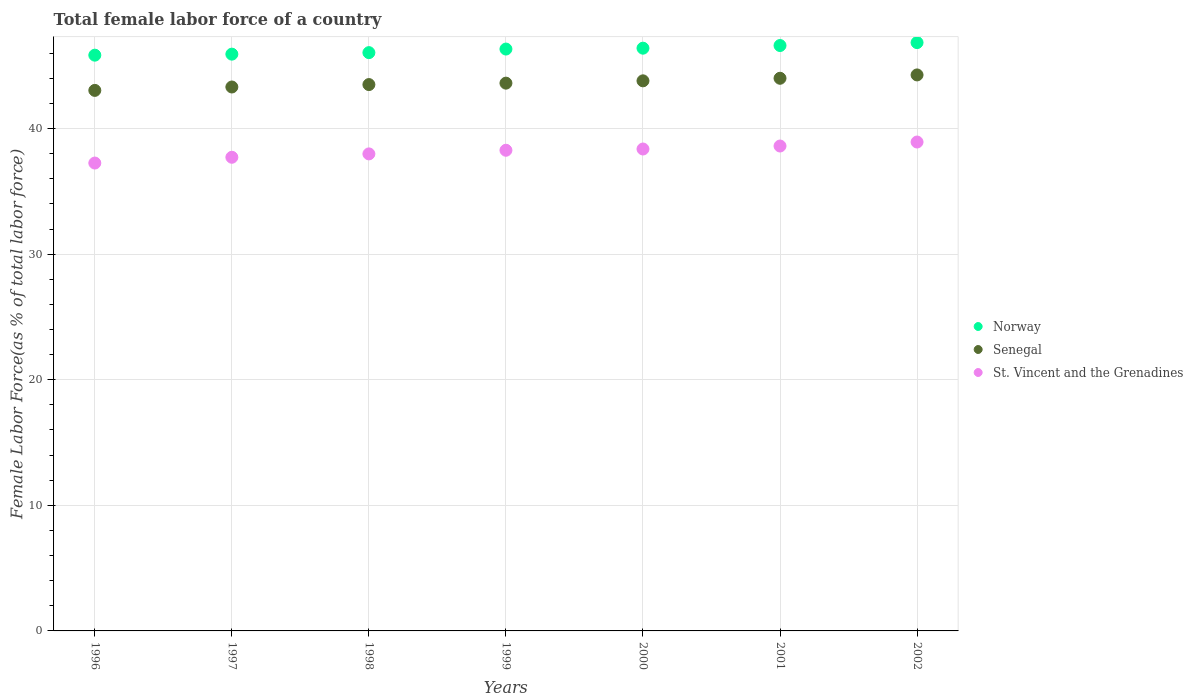Is the number of dotlines equal to the number of legend labels?
Offer a terse response. Yes. What is the percentage of female labor force in Norway in 2002?
Keep it short and to the point. 46.85. Across all years, what is the maximum percentage of female labor force in St. Vincent and the Grenadines?
Provide a short and direct response. 38.93. Across all years, what is the minimum percentage of female labor force in Norway?
Your answer should be compact. 45.85. In which year was the percentage of female labor force in St. Vincent and the Grenadines maximum?
Your response must be concise. 2002. In which year was the percentage of female labor force in St. Vincent and the Grenadines minimum?
Your response must be concise. 1996. What is the total percentage of female labor force in Senegal in the graph?
Your answer should be compact. 305.56. What is the difference between the percentage of female labor force in St. Vincent and the Grenadines in 1998 and that in 2001?
Offer a terse response. -0.63. What is the difference between the percentage of female labor force in Norway in 1998 and the percentage of female labor force in Senegal in 1997?
Provide a short and direct response. 2.74. What is the average percentage of female labor force in Senegal per year?
Keep it short and to the point. 43.65. In the year 1999, what is the difference between the percentage of female labor force in St. Vincent and the Grenadines and percentage of female labor force in Norway?
Keep it short and to the point. -8.06. In how many years, is the percentage of female labor force in Senegal greater than 34 %?
Offer a very short reply. 7. What is the ratio of the percentage of female labor force in Norway in 1997 to that in 1999?
Your answer should be compact. 0.99. Is the percentage of female labor force in Senegal in 1999 less than that in 2000?
Your response must be concise. Yes. What is the difference between the highest and the second highest percentage of female labor force in Senegal?
Provide a succinct answer. 0.27. What is the difference between the highest and the lowest percentage of female labor force in Norway?
Provide a succinct answer. 1. Is the sum of the percentage of female labor force in Senegal in 1999 and 2001 greater than the maximum percentage of female labor force in St. Vincent and the Grenadines across all years?
Keep it short and to the point. Yes. Is it the case that in every year, the sum of the percentage of female labor force in Norway and percentage of female labor force in Senegal  is greater than the percentage of female labor force in St. Vincent and the Grenadines?
Make the answer very short. Yes. Is the percentage of female labor force in Senegal strictly greater than the percentage of female labor force in St. Vincent and the Grenadines over the years?
Make the answer very short. Yes. Is the percentage of female labor force in St. Vincent and the Grenadines strictly less than the percentage of female labor force in Senegal over the years?
Your response must be concise. Yes. How many dotlines are there?
Provide a succinct answer. 3. How many legend labels are there?
Your answer should be compact. 3. What is the title of the graph?
Give a very brief answer. Total female labor force of a country. What is the label or title of the X-axis?
Your response must be concise. Years. What is the label or title of the Y-axis?
Your response must be concise. Female Labor Force(as % of total labor force). What is the Female Labor Force(as % of total labor force) in Norway in 1996?
Keep it short and to the point. 45.85. What is the Female Labor Force(as % of total labor force) of Senegal in 1996?
Keep it short and to the point. 43.04. What is the Female Labor Force(as % of total labor force) of St. Vincent and the Grenadines in 1996?
Your response must be concise. 37.26. What is the Female Labor Force(as % of total labor force) in Norway in 1997?
Your response must be concise. 45.93. What is the Female Labor Force(as % of total labor force) in Senegal in 1997?
Keep it short and to the point. 43.31. What is the Female Labor Force(as % of total labor force) of St. Vincent and the Grenadines in 1997?
Offer a very short reply. 37.72. What is the Female Labor Force(as % of total labor force) of Norway in 1998?
Keep it short and to the point. 46.05. What is the Female Labor Force(as % of total labor force) in Senegal in 1998?
Offer a very short reply. 43.51. What is the Female Labor Force(as % of total labor force) of St. Vincent and the Grenadines in 1998?
Offer a very short reply. 37.99. What is the Female Labor Force(as % of total labor force) of Norway in 1999?
Provide a succinct answer. 46.33. What is the Female Labor Force(as % of total labor force) of Senegal in 1999?
Offer a terse response. 43.62. What is the Female Labor Force(as % of total labor force) in St. Vincent and the Grenadines in 1999?
Provide a succinct answer. 38.27. What is the Female Labor Force(as % of total labor force) of Norway in 2000?
Provide a short and direct response. 46.4. What is the Female Labor Force(as % of total labor force) of Senegal in 2000?
Your answer should be compact. 43.8. What is the Female Labor Force(as % of total labor force) in St. Vincent and the Grenadines in 2000?
Your answer should be very brief. 38.37. What is the Female Labor Force(as % of total labor force) in Norway in 2001?
Provide a short and direct response. 46.61. What is the Female Labor Force(as % of total labor force) in Senegal in 2001?
Provide a short and direct response. 44.01. What is the Female Labor Force(as % of total labor force) of St. Vincent and the Grenadines in 2001?
Keep it short and to the point. 38.61. What is the Female Labor Force(as % of total labor force) in Norway in 2002?
Ensure brevity in your answer.  46.85. What is the Female Labor Force(as % of total labor force) in Senegal in 2002?
Provide a short and direct response. 44.27. What is the Female Labor Force(as % of total labor force) of St. Vincent and the Grenadines in 2002?
Give a very brief answer. 38.93. Across all years, what is the maximum Female Labor Force(as % of total labor force) in Norway?
Keep it short and to the point. 46.85. Across all years, what is the maximum Female Labor Force(as % of total labor force) in Senegal?
Make the answer very short. 44.27. Across all years, what is the maximum Female Labor Force(as % of total labor force) in St. Vincent and the Grenadines?
Your answer should be very brief. 38.93. Across all years, what is the minimum Female Labor Force(as % of total labor force) of Norway?
Provide a succinct answer. 45.85. Across all years, what is the minimum Female Labor Force(as % of total labor force) of Senegal?
Offer a very short reply. 43.04. Across all years, what is the minimum Female Labor Force(as % of total labor force) of St. Vincent and the Grenadines?
Your response must be concise. 37.26. What is the total Female Labor Force(as % of total labor force) in Norway in the graph?
Your response must be concise. 324.02. What is the total Female Labor Force(as % of total labor force) of Senegal in the graph?
Provide a succinct answer. 305.56. What is the total Female Labor Force(as % of total labor force) in St. Vincent and the Grenadines in the graph?
Your response must be concise. 267.15. What is the difference between the Female Labor Force(as % of total labor force) of Norway in 1996 and that in 1997?
Offer a very short reply. -0.08. What is the difference between the Female Labor Force(as % of total labor force) in Senegal in 1996 and that in 1997?
Ensure brevity in your answer.  -0.27. What is the difference between the Female Labor Force(as % of total labor force) in St. Vincent and the Grenadines in 1996 and that in 1997?
Offer a very short reply. -0.46. What is the difference between the Female Labor Force(as % of total labor force) in Norway in 1996 and that in 1998?
Ensure brevity in your answer.  -0.2. What is the difference between the Female Labor Force(as % of total labor force) of Senegal in 1996 and that in 1998?
Provide a short and direct response. -0.46. What is the difference between the Female Labor Force(as % of total labor force) of St. Vincent and the Grenadines in 1996 and that in 1998?
Your answer should be very brief. -0.73. What is the difference between the Female Labor Force(as % of total labor force) of Norway in 1996 and that in 1999?
Ensure brevity in your answer.  -0.49. What is the difference between the Female Labor Force(as % of total labor force) in Senegal in 1996 and that in 1999?
Your answer should be compact. -0.58. What is the difference between the Female Labor Force(as % of total labor force) of St. Vincent and the Grenadines in 1996 and that in 1999?
Provide a succinct answer. -1.02. What is the difference between the Female Labor Force(as % of total labor force) of Norway in 1996 and that in 2000?
Keep it short and to the point. -0.56. What is the difference between the Female Labor Force(as % of total labor force) of Senegal in 1996 and that in 2000?
Make the answer very short. -0.76. What is the difference between the Female Labor Force(as % of total labor force) of St. Vincent and the Grenadines in 1996 and that in 2000?
Offer a very short reply. -1.12. What is the difference between the Female Labor Force(as % of total labor force) in Norway in 1996 and that in 2001?
Your answer should be compact. -0.77. What is the difference between the Female Labor Force(as % of total labor force) in Senegal in 1996 and that in 2001?
Offer a very short reply. -0.97. What is the difference between the Female Labor Force(as % of total labor force) in St. Vincent and the Grenadines in 1996 and that in 2001?
Offer a terse response. -1.36. What is the difference between the Female Labor Force(as % of total labor force) in Norway in 1996 and that in 2002?
Offer a terse response. -1. What is the difference between the Female Labor Force(as % of total labor force) in Senegal in 1996 and that in 2002?
Provide a short and direct response. -1.23. What is the difference between the Female Labor Force(as % of total labor force) in St. Vincent and the Grenadines in 1996 and that in 2002?
Offer a very short reply. -1.67. What is the difference between the Female Labor Force(as % of total labor force) of Norway in 1997 and that in 1998?
Give a very brief answer. -0.12. What is the difference between the Female Labor Force(as % of total labor force) in Senegal in 1997 and that in 1998?
Provide a short and direct response. -0.19. What is the difference between the Female Labor Force(as % of total labor force) in St. Vincent and the Grenadines in 1997 and that in 1998?
Your response must be concise. -0.27. What is the difference between the Female Labor Force(as % of total labor force) of Norway in 1997 and that in 1999?
Give a very brief answer. -0.41. What is the difference between the Female Labor Force(as % of total labor force) of Senegal in 1997 and that in 1999?
Offer a very short reply. -0.31. What is the difference between the Female Labor Force(as % of total labor force) of St. Vincent and the Grenadines in 1997 and that in 1999?
Make the answer very short. -0.56. What is the difference between the Female Labor Force(as % of total labor force) in Norway in 1997 and that in 2000?
Your answer should be very brief. -0.48. What is the difference between the Female Labor Force(as % of total labor force) in Senegal in 1997 and that in 2000?
Ensure brevity in your answer.  -0.49. What is the difference between the Female Labor Force(as % of total labor force) in St. Vincent and the Grenadines in 1997 and that in 2000?
Provide a succinct answer. -0.66. What is the difference between the Female Labor Force(as % of total labor force) of Norway in 1997 and that in 2001?
Ensure brevity in your answer.  -0.69. What is the difference between the Female Labor Force(as % of total labor force) in Senegal in 1997 and that in 2001?
Make the answer very short. -0.69. What is the difference between the Female Labor Force(as % of total labor force) of St. Vincent and the Grenadines in 1997 and that in 2001?
Give a very brief answer. -0.9. What is the difference between the Female Labor Force(as % of total labor force) of Norway in 1997 and that in 2002?
Make the answer very short. -0.92. What is the difference between the Female Labor Force(as % of total labor force) in Senegal in 1997 and that in 2002?
Provide a succinct answer. -0.96. What is the difference between the Female Labor Force(as % of total labor force) of St. Vincent and the Grenadines in 1997 and that in 2002?
Provide a short and direct response. -1.21. What is the difference between the Female Labor Force(as % of total labor force) in Norway in 1998 and that in 1999?
Keep it short and to the point. -0.28. What is the difference between the Female Labor Force(as % of total labor force) in Senegal in 1998 and that in 1999?
Your answer should be very brief. -0.11. What is the difference between the Female Labor Force(as % of total labor force) in St. Vincent and the Grenadines in 1998 and that in 1999?
Provide a short and direct response. -0.29. What is the difference between the Female Labor Force(as % of total labor force) of Norway in 1998 and that in 2000?
Provide a succinct answer. -0.35. What is the difference between the Female Labor Force(as % of total labor force) in Senegal in 1998 and that in 2000?
Offer a terse response. -0.3. What is the difference between the Female Labor Force(as % of total labor force) in St. Vincent and the Grenadines in 1998 and that in 2000?
Offer a terse response. -0.39. What is the difference between the Female Labor Force(as % of total labor force) of Norway in 1998 and that in 2001?
Your response must be concise. -0.57. What is the difference between the Female Labor Force(as % of total labor force) in Senegal in 1998 and that in 2001?
Make the answer very short. -0.5. What is the difference between the Female Labor Force(as % of total labor force) of St. Vincent and the Grenadines in 1998 and that in 2001?
Keep it short and to the point. -0.63. What is the difference between the Female Labor Force(as % of total labor force) of Norway in 1998 and that in 2002?
Keep it short and to the point. -0.8. What is the difference between the Female Labor Force(as % of total labor force) in Senegal in 1998 and that in 2002?
Ensure brevity in your answer.  -0.77. What is the difference between the Female Labor Force(as % of total labor force) of St. Vincent and the Grenadines in 1998 and that in 2002?
Give a very brief answer. -0.95. What is the difference between the Female Labor Force(as % of total labor force) of Norway in 1999 and that in 2000?
Ensure brevity in your answer.  -0.07. What is the difference between the Female Labor Force(as % of total labor force) of Senegal in 1999 and that in 2000?
Your answer should be compact. -0.18. What is the difference between the Female Labor Force(as % of total labor force) in St. Vincent and the Grenadines in 1999 and that in 2000?
Your response must be concise. -0.1. What is the difference between the Female Labor Force(as % of total labor force) of Norway in 1999 and that in 2001?
Ensure brevity in your answer.  -0.28. What is the difference between the Female Labor Force(as % of total labor force) in Senegal in 1999 and that in 2001?
Your answer should be compact. -0.39. What is the difference between the Female Labor Force(as % of total labor force) in St. Vincent and the Grenadines in 1999 and that in 2001?
Keep it short and to the point. -0.34. What is the difference between the Female Labor Force(as % of total labor force) in Norway in 1999 and that in 2002?
Give a very brief answer. -0.51. What is the difference between the Female Labor Force(as % of total labor force) in Senegal in 1999 and that in 2002?
Offer a very short reply. -0.65. What is the difference between the Female Labor Force(as % of total labor force) of St. Vincent and the Grenadines in 1999 and that in 2002?
Provide a short and direct response. -0.66. What is the difference between the Female Labor Force(as % of total labor force) of Norway in 2000 and that in 2001?
Provide a short and direct response. -0.21. What is the difference between the Female Labor Force(as % of total labor force) of Senegal in 2000 and that in 2001?
Your answer should be compact. -0.2. What is the difference between the Female Labor Force(as % of total labor force) in St. Vincent and the Grenadines in 2000 and that in 2001?
Provide a succinct answer. -0.24. What is the difference between the Female Labor Force(as % of total labor force) of Norway in 2000 and that in 2002?
Offer a terse response. -0.44. What is the difference between the Female Labor Force(as % of total labor force) of Senegal in 2000 and that in 2002?
Give a very brief answer. -0.47. What is the difference between the Female Labor Force(as % of total labor force) in St. Vincent and the Grenadines in 2000 and that in 2002?
Provide a succinct answer. -0.56. What is the difference between the Female Labor Force(as % of total labor force) in Norway in 2001 and that in 2002?
Your response must be concise. -0.23. What is the difference between the Female Labor Force(as % of total labor force) of Senegal in 2001 and that in 2002?
Offer a terse response. -0.27. What is the difference between the Female Labor Force(as % of total labor force) in St. Vincent and the Grenadines in 2001 and that in 2002?
Provide a short and direct response. -0.32. What is the difference between the Female Labor Force(as % of total labor force) of Norway in 1996 and the Female Labor Force(as % of total labor force) of Senegal in 1997?
Offer a very short reply. 2.53. What is the difference between the Female Labor Force(as % of total labor force) in Norway in 1996 and the Female Labor Force(as % of total labor force) in St. Vincent and the Grenadines in 1997?
Make the answer very short. 8.13. What is the difference between the Female Labor Force(as % of total labor force) of Senegal in 1996 and the Female Labor Force(as % of total labor force) of St. Vincent and the Grenadines in 1997?
Keep it short and to the point. 5.33. What is the difference between the Female Labor Force(as % of total labor force) of Norway in 1996 and the Female Labor Force(as % of total labor force) of Senegal in 1998?
Make the answer very short. 2.34. What is the difference between the Female Labor Force(as % of total labor force) in Norway in 1996 and the Female Labor Force(as % of total labor force) in St. Vincent and the Grenadines in 1998?
Make the answer very short. 7.86. What is the difference between the Female Labor Force(as % of total labor force) of Senegal in 1996 and the Female Labor Force(as % of total labor force) of St. Vincent and the Grenadines in 1998?
Provide a succinct answer. 5.06. What is the difference between the Female Labor Force(as % of total labor force) in Norway in 1996 and the Female Labor Force(as % of total labor force) in Senegal in 1999?
Provide a succinct answer. 2.23. What is the difference between the Female Labor Force(as % of total labor force) in Norway in 1996 and the Female Labor Force(as % of total labor force) in St. Vincent and the Grenadines in 1999?
Your response must be concise. 7.57. What is the difference between the Female Labor Force(as % of total labor force) in Senegal in 1996 and the Female Labor Force(as % of total labor force) in St. Vincent and the Grenadines in 1999?
Give a very brief answer. 4.77. What is the difference between the Female Labor Force(as % of total labor force) of Norway in 1996 and the Female Labor Force(as % of total labor force) of Senegal in 2000?
Give a very brief answer. 2.04. What is the difference between the Female Labor Force(as % of total labor force) of Norway in 1996 and the Female Labor Force(as % of total labor force) of St. Vincent and the Grenadines in 2000?
Keep it short and to the point. 7.47. What is the difference between the Female Labor Force(as % of total labor force) of Senegal in 1996 and the Female Labor Force(as % of total labor force) of St. Vincent and the Grenadines in 2000?
Ensure brevity in your answer.  4.67. What is the difference between the Female Labor Force(as % of total labor force) in Norway in 1996 and the Female Labor Force(as % of total labor force) in Senegal in 2001?
Your response must be concise. 1.84. What is the difference between the Female Labor Force(as % of total labor force) of Norway in 1996 and the Female Labor Force(as % of total labor force) of St. Vincent and the Grenadines in 2001?
Provide a short and direct response. 7.23. What is the difference between the Female Labor Force(as % of total labor force) of Senegal in 1996 and the Female Labor Force(as % of total labor force) of St. Vincent and the Grenadines in 2001?
Your response must be concise. 4.43. What is the difference between the Female Labor Force(as % of total labor force) in Norway in 1996 and the Female Labor Force(as % of total labor force) in Senegal in 2002?
Offer a terse response. 1.57. What is the difference between the Female Labor Force(as % of total labor force) of Norway in 1996 and the Female Labor Force(as % of total labor force) of St. Vincent and the Grenadines in 2002?
Ensure brevity in your answer.  6.92. What is the difference between the Female Labor Force(as % of total labor force) of Senegal in 1996 and the Female Labor Force(as % of total labor force) of St. Vincent and the Grenadines in 2002?
Your answer should be very brief. 4.11. What is the difference between the Female Labor Force(as % of total labor force) in Norway in 1997 and the Female Labor Force(as % of total labor force) in Senegal in 1998?
Your response must be concise. 2.42. What is the difference between the Female Labor Force(as % of total labor force) of Norway in 1997 and the Female Labor Force(as % of total labor force) of St. Vincent and the Grenadines in 1998?
Offer a very short reply. 7.94. What is the difference between the Female Labor Force(as % of total labor force) in Senegal in 1997 and the Female Labor Force(as % of total labor force) in St. Vincent and the Grenadines in 1998?
Your response must be concise. 5.33. What is the difference between the Female Labor Force(as % of total labor force) of Norway in 1997 and the Female Labor Force(as % of total labor force) of Senegal in 1999?
Your answer should be compact. 2.31. What is the difference between the Female Labor Force(as % of total labor force) in Norway in 1997 and the Female Labor Force(as % of total labor force) in St. Vincent and the Grenadines in 1999?
Ensure brevity in your answer.  7.65. What is the difference between the Female Labor Force(as % of total labor force) in Senegal in 1997 and the Female Labor Force(as % of total labor force) in St. Vincent and the Grenadines in 1999?
Give a very brief answer. 5.04. What is the difference between the Female Labor Force(as % of total labor force) in Norway in 1997 and the Female Labor Force(as % of total labor force) in Senegal in 2000?
Provide a short and direct response. 2.12. What is the difference between the Female Labor Force(as % of total labor force) of Norway in 1997 and the Female Labor Force(as % of total labor force) of St. Vincent and the Grenadines in 2000?
Provide a short and direct response. 7.55. What is the difference between the Female Labor Force(as % of total labor force) of Senegal in 1997 and the Female Labor Force(as % of total labor force) of St. Vincent and the Grenadines in 2000?
Your answer should be very brief. 4.94. What is the difference between the Female Labor Force(as % of total labor force) in Norway in 1997 and the Female Labor Force(as % of total labor force) in Senegal in 2001?
Provide a succinct answer. 1.92. What is the difference between the Female Labor Force(as % of total labor force) of Norway in 1997 and the Female Labor Force(as % of total labor force) of St. Vincent and the Grenadines in 2001?
Make the answer very short. 7.32. What is the difference between the Female Labor Force(as % of total labor force) of Senegal in 1997 and the Female Labor Force(as % of total labor force) of St. Vincent and the Grenadines in 2001?
Your answer should be compact. 4.7. What is the difference between the Female Labor Force(as % of total labor force) in Norway in 1997 and the Female Labor Force(as % of total labor force) in Senegal in 2002?
Offer a very short reply. 1.65. What is the difference between the Female Labor Force(as % of total labor force) in Norway in 1997 and the Female Labor Force(as % of total labor force) in St. Vincent and the Grenadines in 2002?
Offer a very short reply. 7. What is the difference between the Female Labor Force(as % of total labor force) of Senegal in 1997 and the Female Labor Force(as % of total labor force) of St. Vincent and the Grenadines in 2002?
Keep it short and to the point. 4.38. What is the difference between the Female Labor Force(as % of total labor force) in Norway in 1998 and the Female Labor Force(as % of total labor force) in Senegal in 1999?
Keep it short and to the point. 2.43. What is the difference between the Female Labor Force(as % of total labor force) of Norway in 1998 and the Female Labor Force(as % of total labor force) of St. Vincent and the Grenadines in 1999?
Your answer should be very brief. 7.77. What is the difference between the Female Labor Force(as % of total labor force) of Senegal in 1998 and the Female Labor Force(as % of total labor force) of St. Vincent and the Grenadines in 1999?
Offer a very short reply. 5.23. What is the difference between the Female Labor Force(as % of total labor force) in Norway in 1998 and the Female Labor Force(as % of total labor force) in Senegal in 2000?
Give a very brief answer. 2.25. What is the difference between the Female Labor Force(as % of total labor force) of Norway in 1998 and the Female Labor Force(as % of total labor force) of St. Vincent and the Grenadines in 2000?
Provide a short and direct response. 7.67. What is the difference between the Female Labor Force(as % of total labor force) of Senegal in 1998 and the Female Labor Force(as % of total labor force) of St. Vincent and the Grenadines in 2000?
Offer a very short reply. 5.13. What is the difference between the Female Labor Force(as % of total labor force) in Norway in 1998 and the Female Labor Force(as % of total labor force) in Senegal in 2001?
Your answer should be very brief. 2.04. What is the difference between the Female Labor Force(as % of total labor force) in Norway in 1998 and the Female Labor Force(as % of total labor force) in St. Vincent and the Grenadines in 2001?
Offer a terse response. 7.44. What is the difference between the Female Labor Force(as % of total labor force) of Senegal in 1998 and the Female Labor Force(as % of total labor force) of St. Vincent and the Grenadines in 2001?
Give a very brief answer. 4.89. What is the difference between the Female Labor Force(as % of total labor force) in Norway in 1998 and the Female Labor Force(as % of total labor force) in Senegal in 2002?
Keep it short and to the point. 1.77. What is the difference between the Female Labor Force(as % of total labor force) in Norway in 1998 and the Female Labor Force(as % of total labor force) in St. Vincent and the Grenadines in 2002?
Ensure brevity in your answer.  7.12. What is the difference between the Female Labor Force(as % of total labor force) in Senegal in 1998 and the Female Labor Force(as % of total labor force) in St. Vincent and the Grenadines in 2002?
Offer a terse response. 4.57. What is the difference between the Female Labor Force(as % of total labor force) in Norway in 1999 and the Female Labor Force(as % of total labor force) in Senegal in 2000?
Make the answer very short. 2.53. What is the difference between the Female Labor Force(as % of total labor force) of Norway in 1999 and the Female Labor Force(as % of total labor force) of St. Vincent and the Grenadines in 2000?
Offer a terse response. 7.96. What is the difference between the Female Labor Force(as % of total labor force) in Senegal in 1999 and the Female Labor Force(as % of total labor force) in St. Vincent and the Grenadines in 2000?
Ensure brevity in your answer.  5.24. What is the difference between the Female Labor Force(as % of total labor force) in Norway in 1999 and the Female Labor Force(as % of total labor force) in Senegal in 2001?
Make the answer very short. 2.33. What is the difference between the Female Labor Force(as % of total labor force) in Norway in 1999 and the Female Labor Force(as % of total labor force) in St. Vincent and the Grenadines in 2001?
Your response must be concise. 7.72. What is the difference between the Female Labor Force(as % of total labor force) of Senegal in 1999 and the Female Labor Force(as % of total labor force) of St. Vincent and the Grenadines in 2001?
Your answer should be compact. 5.01. What is the difference between the Female Labor Force(as % of total labor force) of Norway in 1999 and the Female Labor Force(as % of total labor force) of Senegal in 2002?
Keep it short and to the point. 2.06. What is the difference between the Female Labor Force(as % of total labor force) of Norway in 1999 and the Female Labor Force(as % of total labor force) of St. Vincent and the Grenadines in 2002?
Keep it short and to the point. 7.4. What is the difference between the Female Labor Force(as % of total labor force) in Senegal in 1999 and the Female Labor Force(as % of total labor force) in St. Vincent and the Grenadines in 2002?
Offer a terse response. 4.69. What is the difference between the Female Labor Force(as % of total labor force) in Norway in 2000 and the Female Labor Force(as % of total labor force) in Senegal in 2001?
Provide a short and direct response. 2.4. What is the difference between the Female Labor Force(as % of total labor force) in Norway in 2000 and the Female Labor Force(as % of total labor force) in St. Vincent and the Grenadines in 2001?
Ensure brevity in your answer.  7.79. What is the difference between the Female Labor Force(as % of total labor force) in Senegal in 2000 and the Female Labor Force(as % of total labor force) in St. Vincent and the Grenadines in 2001?
Offer a terse response. 5.19. What is the difference between the Female Labor Force(as % of total labor force) in Norway in 2000 and the Female Labor Force(as % of total labor force) in Senegal in 2002?
Your answer should be compact. 2.13. What is the difference between the Female Labor Force(as % of total labor force) in Norway in 2000 and the Female Labor Force(as % of total labor force) in St. Vincent and the Grenadines in 2002?
Give a very brief answer. 7.47. What is the difference between the Female Labor Force(as % of total labor force) of Senegal in 2000 and the Female Labor Force(as % of total labor force) of St. Vincent and the Grenadines in 2002?
Ensure brevity in your answer.  4.87. What is the difference between the Female Labor Force(as % of total labor force) of Norway in 2001 and the Female Labor Force(as % of total labor force) of Senegal in 2002?
Provide a short and direct response. 2.34. What is the difference between the Female Labor Force(as % of total labor force) of Norway in 2001 and the Female Labor Force(as % of total labor force) of St. Vincent and the Grenadines in 2002?
Your response must be concise. 7.68. What is the difference between the Female Labor Force(as % of total labor force) in Senegal in 2001 and the Female Labor Force(as % of total labor force) in St. Vincent and the Grenadines in 2002?
Provide a succinct answer. 5.08. What is the average Female Labor Force(as % of total labor force) in Norway per year?
Make the answer very short. 46.29. What is the average Female Labor Force(as % of total labor force) of Senegal per year?
Your answer should be compact. 43.65. What is the average Female Labor Force(as % of total labor force) of St. Vincent and the Grenadines per year?
Make the answer very short. 38.16. In the year 1996, what is the difference between the Female Labor Force(as % of total labor force) in Norway and Female Labor Force(as % of total labor force) in Senegal?
Ensure brevity in your answer.  2.8. In the year 1996, what is the difference between the Female Labor Force(as % of total labor force) in Norway and Female Labor Force(as % of total labor force) in St. Vincent and the Grenadines?
Your answer should be very brief. 8.59. In the year 1996, what is the difference between the Female Labor Force(as % of total labor force) of Senegal and Female Labor Force(as % of total labor force) of St. Vincent and the Grenadines?
Your answer should be compact. 5.79. In the year 1997, what is the difference between the Female Labor Force(as % of total labor force) in Norway and Female Labor Force(as % of total labor force) in Senegal?
Offer a terse response. 2.62. In the year 1997, what is the difference between the Female Labor Force(as % of total labor force) of Norway and Female Labor Force(as % of total labor force) of St. Vincent and the Grenadines?
Your response must be concise. 8.21. In the year 1997, what is the difference between the Female Labor Force(as % of total labor force) in Senegal and Female Labor Force(as % of total labor force) in St. Vincent and the Grenadines?
Provide a short and direct response. 5.6. In the year 1998, what is the difference between the Female Labor Force(as % of total labor force) in Norway and Female Labor Force(as % of total labor force) in Senegal?
Your response must be concise. 2.54. In the year 1998, what is the difference between the Female Labor Force(as % of total labor force) in Norway and Female Labor Force(as % of total labor force) in St. Vincent and the Grenadines?
Keep it short and to the point. 8.06. In the year 1998, what is the difference between the Female Labor Force(as % of total labor force) in Senegal and Female Labor Force(as % of total labor force) in St. Vincent and the Grenadines?
Your response must be concise. 5.52. In the year 1999, what is the difference between the Female Labor Force(as % of total labor force) in Norway and Female Labor Force(as % of total labor force) in Senegal?
Your response must be concise. 2.71. In the year 1999, what is the difference between the Female Labor Force(as % of total labor force) of Norway and Female Labor Force(as % of total labor force) of St. Vincent and the Grenadines?
Offer a terse response. 8.06. In the year 1999, what is the difference between the Female Labor Force(as % of total labor force) of Senegal and Female Labor Force(as % of total labor force) of St. Vincent and the Grenadines?
Offer a very short reply. 5.34. In the year 2000, what is the difference between the Female Labor Force(as % of total labor force) of Norway and Female Labor Force(as % of total labor force) of Senegal?
Ensure brevity in your answer.  2.6. In the year 2000, what is the difference between the Female Labor Force(as % of total labor force) of Norway and Female Labor Force(as % of total labor force) of St. Vincent and the Grenadines?
Offer a very short reply. 8.03. In the year 2000, what is the difference between the Female Labor Force(as % of total labor force) in Senegal and Female Labor Force(as % of total labor force) in St. Vincent and the Grenadines?
Provide a short and direct response. 5.43. In the year 2001, what is the difference between the Female Labor Force(as % of total labor force) in Norway and Female Labor Force(as % of total labor force) in Senegal?
Provide a succinct answer. 2.61. In the year 2001, what is the difference between the Female Labor Force(as % of total labor force) in Norway and Female Labor Force(as % of total labor force) in St. Vincent and the Grenadines?
Keep it short and to the point. 8. In the year 2001, what is the difference between the Female Labor Force(as % of total labor force) in Senegal and Female Labor Force(as % of total labor force) in St. Vincent and the Grenadines?
Your answer should be compact. 5.39. In the year 2002, what is the difference between the Female Labor Force(as % of total labor force) of Norway and Female Labor Force(as % of total labor force) of Senegal?
Offer a terse response. 2.57. In the year 2002, what is the difference between the Female Labor Force(as % of total labor force) of Norway and Female Labor Force(as % of total labor force) of St. Vincent and the Grenadines?
Provide a succinct answer. 7.92. In the year 2002, what is the difference between the Female Labor Force(as % of total labor force) in Senegal and Female Labor Force(as % of total labor force) in St. Vincent and the Grenadines?
Provide a succinct answer. 5.34. What is the ratio of the Female Labor Force(as % of total labor force) in Norway in 1996 to that in 1997?
Your answer should be compact. 1. What is the ratio of the Female Labor Force(as % of total labor force) of St. Vincent and the Grenadines in 1996 to that in 1997?
Ensure brevity in your answer.  0.99. What is the ratio of the Female Labor Force(as % of total labor force) of Norway in 1996 to that in 1998?
Provide a short and direct response. 1. What is the ratio of the Female Labor Force(as % of total labor force) in Senegal in 1996 to that in 1998?
Provide a short and direct response. 0.99. What is the ratio of the Female Labor Force(as % of total labor force) in St. Vincent and the Grenadines in 1996 to that in 1998?
Ensure brevity in your answer.  0.98. What is the ratio of the Female Labor Force(as % of total labor force) of Norway in 1996 to that in 1999?
Your response must be concise. 0.99. What is the ratio of the Female Labor Force(as % of total labor force) of Senegal in 1996 to that in 1999?
Your answer should be compact. 0.99. What is the ratio of the Female Labor Force(as % of total labor force) in St. Vincent and the Grenadines in 1996 to that in 1999?
Your answer should be compact. 0.97. What is the ratio of the Female Labor Force(as % of total labor force) of Senegal in 1996 to that in 2000?
Offer a terse response. 0.98. What is the ratio of the Female Labor Force(as % of total labor force) in St. Vincent and the Grenadines in 1996 to that in 2000?
Your answer should be very brief. 0.97. What is the ratio of the Female Labor Force(as % of total labor force) in Norway in 1996 to that in 2001?
Ensure brevity in your answer.  0.98. What is the ratio of the Female Labor Force(as % of total labor force) of Senegal in 1996 to that in 2001?
Offer a very short reply. 0.98. What is the ratio of the Female Labor Force(as % of total labor force) in St. Vincent and the Grenadines in 1996 to that in 2001?
Ensure brevity in your answer.  0.96. What is the ratio of the Female Labor Force(as % of total labor force) of Norway in 1996 to that in 2002?
Provide a succinct answer. 0.98. What is the ratio of the Female Labor Force(as % of total labor force) of Senegal in 1996 to that in 2002?
Your response must be concise. 0.97. What is the ratio of the Female Labor Force(as % of total labor force) in St. Vincent and the Grenadines in 1996 to that in 2002?
Give a very brief answer. 0.96. What is the ratio of the Female Labor Force(as % of total labor force) in Norway in 1997 to that in 1998?
Offer a very short reply. 1. What is the ratio of the Female Labor Force(as % of total labor force) in Norway in 1997 to that in 1999?
Offer a very short reply. 0.99. What is the ratio of the Female Labor Force(as % of total labor force) in Senegal in 1997 to that in 1999?
Offer a terse response. 0.99. What is the ratio of the Female Labor Force(as % of total labor force) of St. Vincent and the Grenadines in 1997 to that in 1999?
Offer a terse response. 0.99. What is the ratio of the Female Labor Force(as % of total labor force) in Norway in 1997 to that in 2000?
Offer a terse response. 0.99. What is the ratio of the Female Labor Force(as % of total labor force) of St. Vincent and the Grenadines in 1997 to that in 2000?
Offer a terse response. 0.98. What is the ratio of the Female Labor Force(as % of total labor force) of Norway in 1997 to that in 2001?
Keep it short and to the point. 0.99. What is the ratio of the Female Labor Force(as % of total labor force) of Senegal in 1997 to that in 2001?
Ensure brevity in your answer.  0.98. What is the ratio of the Female Labor Force(as % of total labor force) of St. Vincent and the Grenadines in 1997 to that in 2001?
Your answer should be very brief. 0.98. What is the ratio of the Female Labor Force(as % of total labor force) in Norway in 1997 to that in 2002?
Make the answer very short. 0.98. What is the ratio of the Female Labor Force(as % of total labor force) of Senegal in 1997 to that in 2002?
Provide a succinct answer. 0.98. What is the ratio of the Female Labor Force(as % of total labor force) of St. Vincent and the Grenadines in 1997 to that in 2002?
Keep it short and to the point. 0.97. What is the ratio of the Female Labor Force(as % of total labor force) in Norway in 1998 to that in 1999?
Offer a very short reply. 0.99. What is the ratio of the Female Labor Force(as % of total labor force) of St. Vincent and the Grenadines in 1998 to that in 1999?
Provide a short and direct response. 0.99. What is the ratio of the Female Labor Force(as % of total labor force) of Norway in 1998 to that in 2001?
Ensure brevity in your answer.  0.99. What is the ratio of the Female Labor Force(as % of total labor force) of St. Vincent and the Grenadines in 1998 to that in 2001?
Provide a short and direct response. 0.98. What is the ratio of the Female Labor Force(as % of total labor force) in Norway in 1998 to that in 2002?
Provide a succinct answer. 0.98. What is the ratio of the Female Labor Force(as % of total labor force) of Senegal in 1998 to that in 2002?
Make the answer very short. 0.98. What is the ratio of the Female Labor Force(as % of total labor force) in St. Vincent and the Grenadines in 1998 to that in 2002?
Your answer should be compact. 0.98. What is the ratio of the Female Labor Force(as % of total labor force) of Norway in 1999 to that in 2000?
Offer a very short reply. 1. What is the ratio of the Female Labor Force(as % of total labor force) in Norway in 1999 to that in 2002?
Keep it short and to the point. 0.99. What is the ratio of the Female Labor Force(as % of total labor force) in Senegal in 1999 to that in 2002?
Give a very brief answer. 0.99. What is the ratio of the Female Labor Force(as % of total labor force) of St. Vincent and the Grenadines in 1999 to that in 2002?
Give a very brief answer. 0.98. What is the ratio of the Female Labor Force(as % of total labor force) in St. Vincent and the Grenadines in 2000 to that in 2001?
Your answer should be very brief. 0.99. What is the ratio of the Female Labor Force(as % of total labor force) of Norway in 2000 to that in 2002?
Your response must be concise. 0.99. What is the ratio of the Female Labor Force(as % of total labor force) of St. Vincent and the Grenadines in 2000 to that in 2002?
Your answer should be compact. 0.99. What is the ratio of the Female Labor Force(as % of total labor force) of St. Vincent and the Grenadines in 2001 to that in 2002?
Give a very brief answer. 0.99. What is the difference between the highest and the second highest Female Labor Force(as % of total labor force) in Norway?
Keep it short and to the point. 0.23. What is the difference between the highest and the second highest Female Labor Force(as % of total labor force) of Senegal?
Make the answer very short. 0.27. What is the difference between the highest and the second highest Female Labor Force(as % of total labor force) of St. Vincent and the Grenadines?
Provide a succinct answer. 0.32. What is the difference between the highest and the lowest Female Labor Force(as % of total labor force) of Senegal?
Provide a succinct answer. 1.23. What is the difference between the highest and the lowest Female Labor Force(as % of total labor force) in St. Vincent and the Grenadines?
Provide a succinct answer. 1.67. 